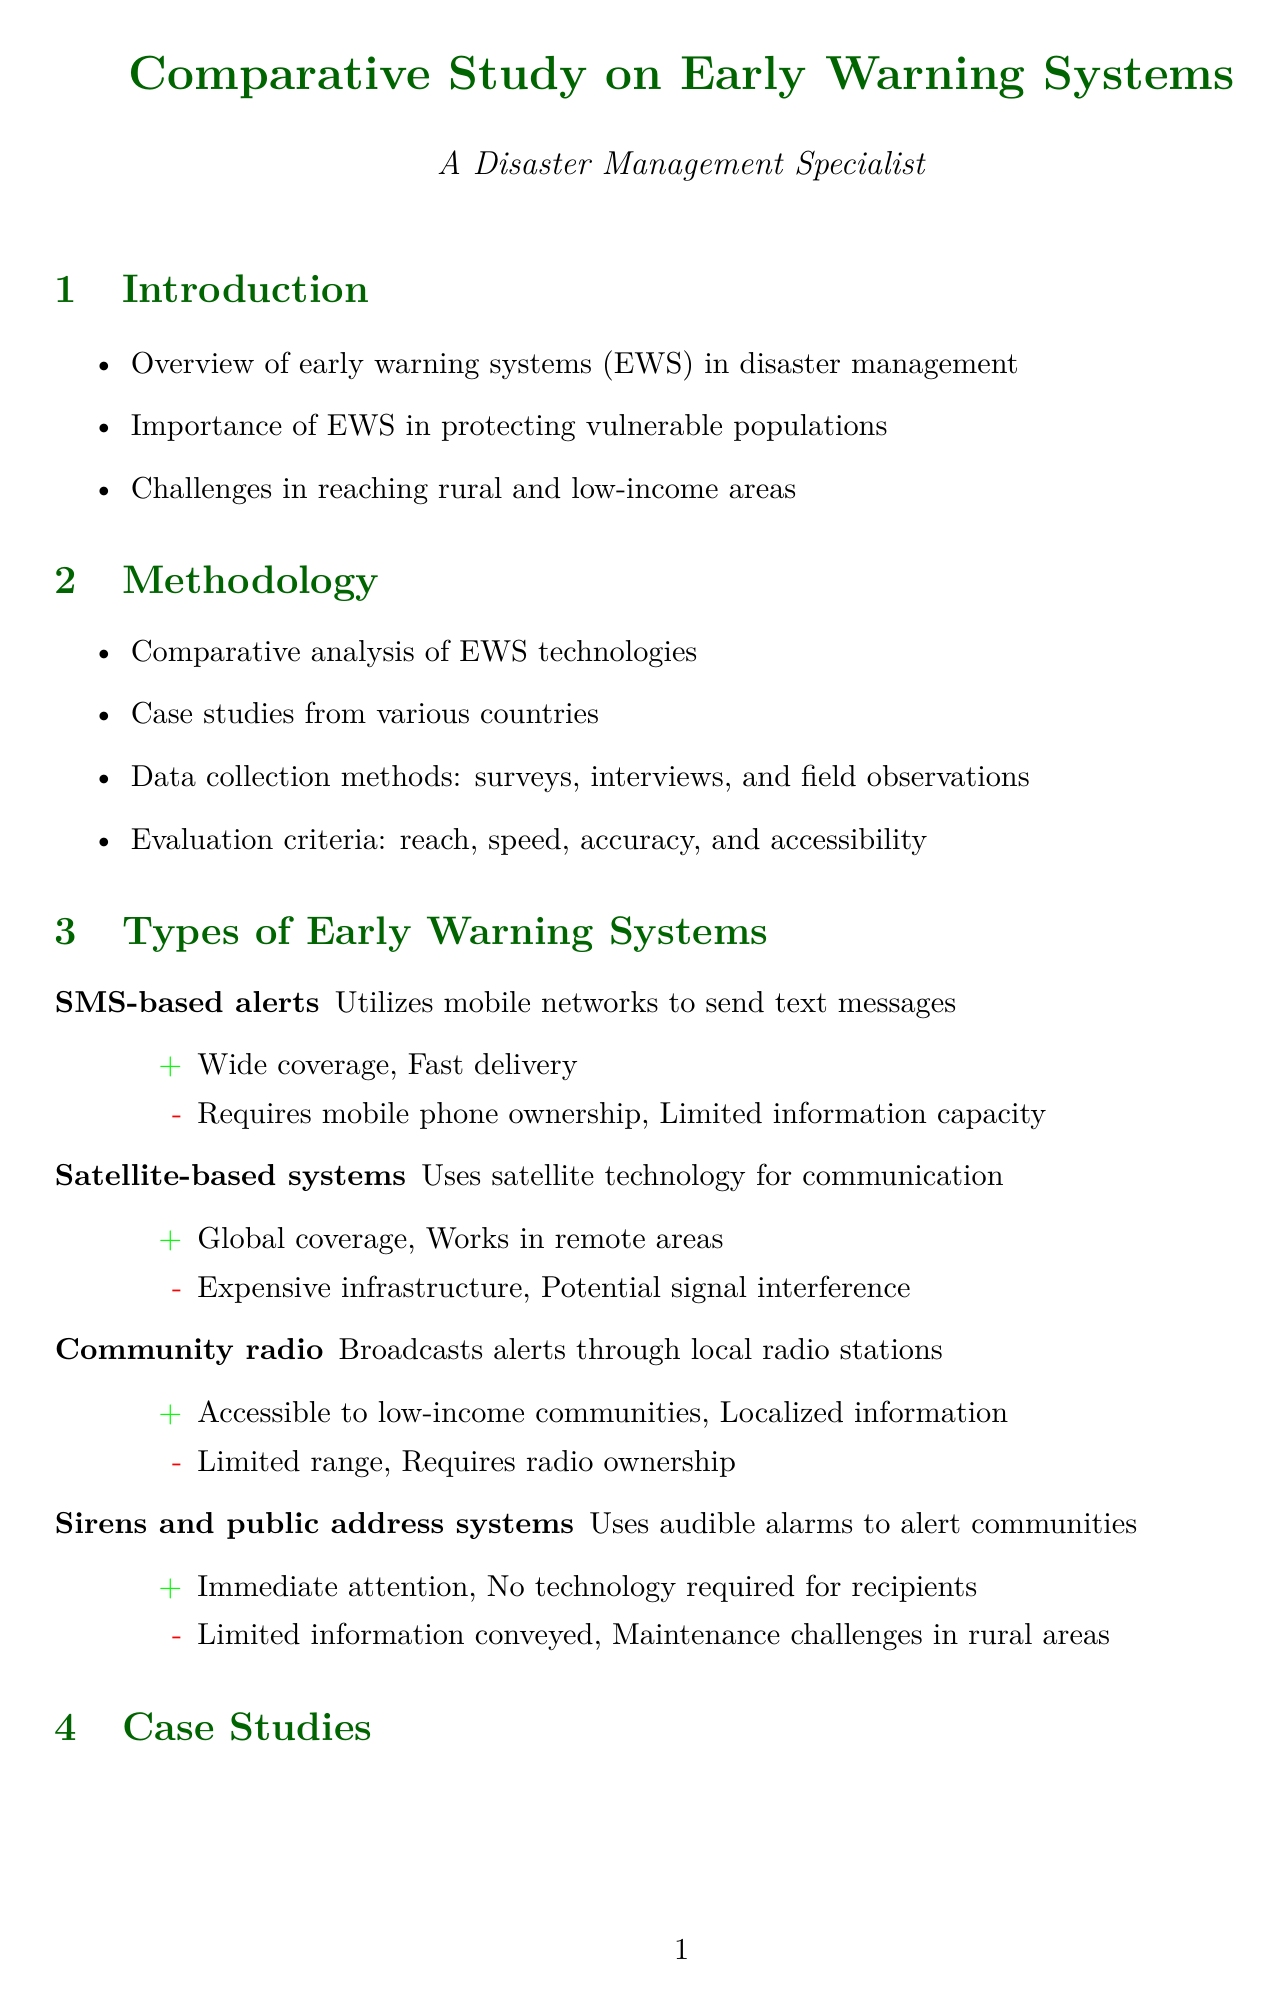What is the main focus of the report? The report focuses on the effectiveness of various early warning systems in reaching vulnerable populations, particularly in rural and low-income areas.
Answer: Effectiveness of early warning systems What is the percentage of rural populations in least developed countries with mobile phone access? The document provides a statistic regarding mobile phone access in rural populations in least developed countries, which is 72%.
Answer: 72% Which early warning system combines multiple technologies and trained volunteers? The system described in Bangladesh that combines multiple technologies with a network of trained volunteers is called the Cyclone Preparedness Programme (CPP).
Answer: Cyclone Preparedness Programme (CPP) What challenge is associated with rural and low-income areas? One of the challenges mentioned in the document is the digital divide and limited access to technology.
Answer: Digital divide What is one recommendation made in the report? One recommendation is to develop multi-channel early warning system approaches to maximize reach.
Answer: Develop multi-channel EWS approaches to maximize reach How many people are still offline globally? The document states that 2.9 billion people are still offline globally.
Answer: 2.9 billion What type of early warning system uses audible alarms? The document mentions sirens and public address systems as the type of early warning system that uses audible alarms.
Answer: Sirens and public address systems Which country has an early warning system called Project NOAH? The Philippines implements the early warning system known as Project NOAH.
Answer: Philippines 